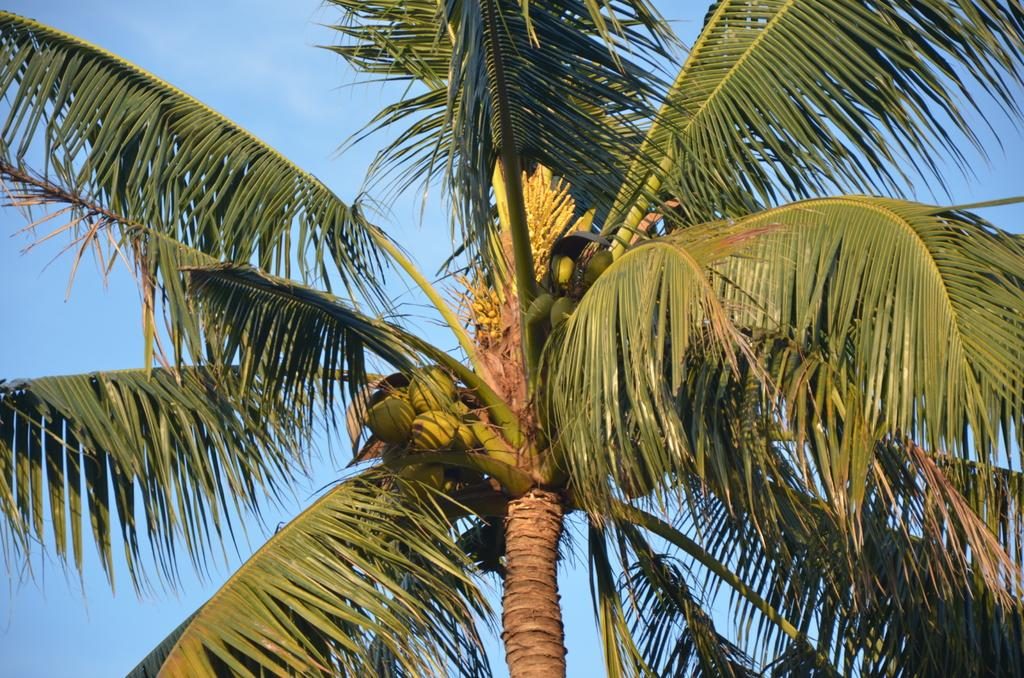What type of plant can be seen in the image? There is a tree in the image. What is hanging from the tree? There are coconuts on the tree. What color is the sky in the image? The sky is blue in color. What sound can be heard coming from the tree in the image? There is no sound present in the image, as it is a still photograph. What type of test is being conducted on the tree in the image? There is no test being conducted on the tree in the image; it is simply a tree with coconuts. 